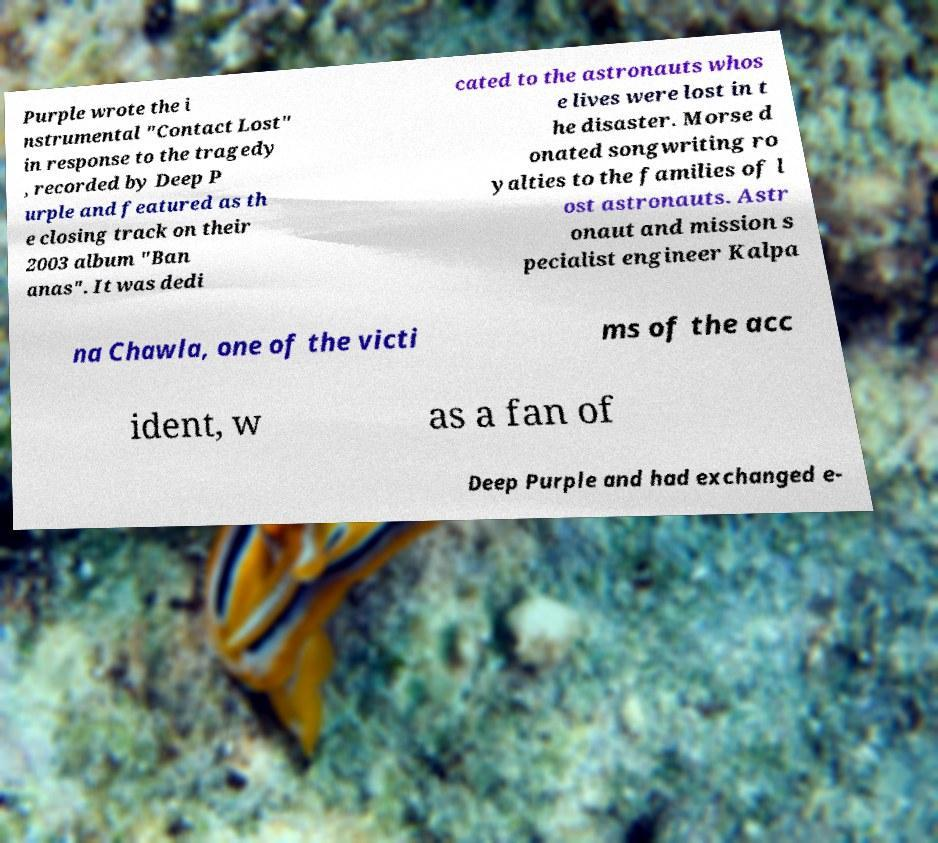Can you accurately transcribe the text from the provided image for me? Purple wrote the i nstrumental "Contact Lost" in response to the tragedy , recorded by Deep P urple and featured as th e closing track on their 2003 album "Ban anas". It was dedi cated to the astronauts whos e lives were lost in t he disaster. Morse d onated songwriting ro yalties to the families of l ost astronauts. Astr onaut and mission s pecialist engineer Kalpa na Chawla, one of the victi ms of the acc ident, w as a fan of Deep Purple and had exchanged e- 